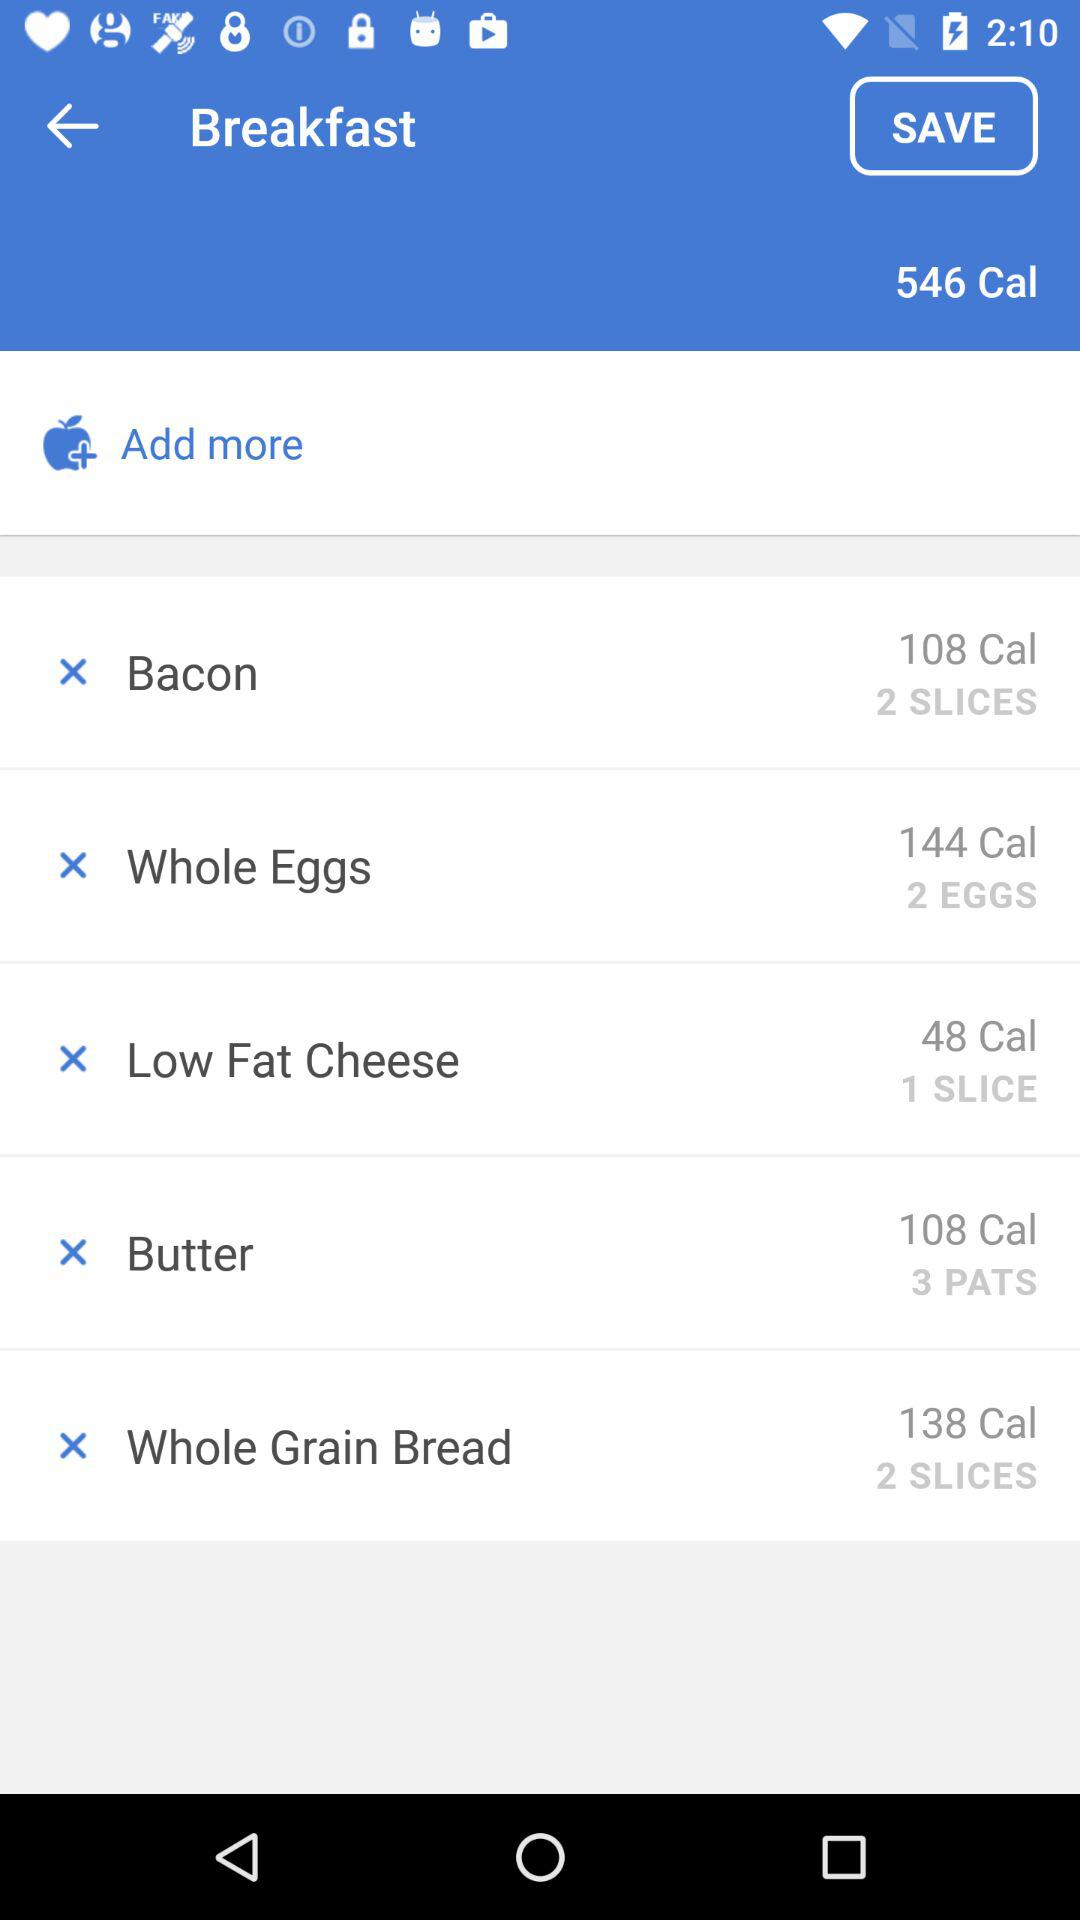How many slices of bacon are in the breakfast?
Answer the question using a single word or phrase. 2 